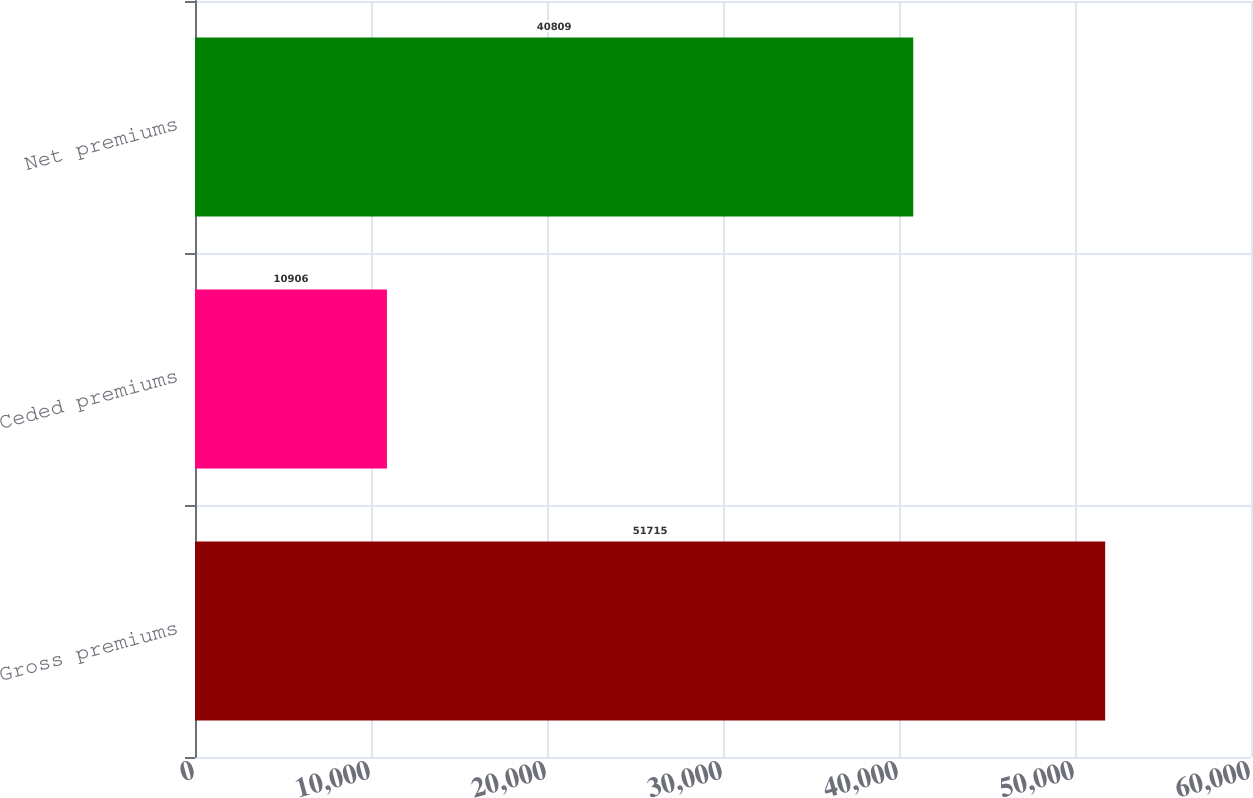Convert chart to OTSL. <chart><loc_0><loc_0><loc_500><loc_500><bar_chart><fcel>Gross premiums<fcel>Ceded premiums<fcel>Net premiums<nl><fcel>51715<fcel>10906<fcel>40809<nl></chart> 